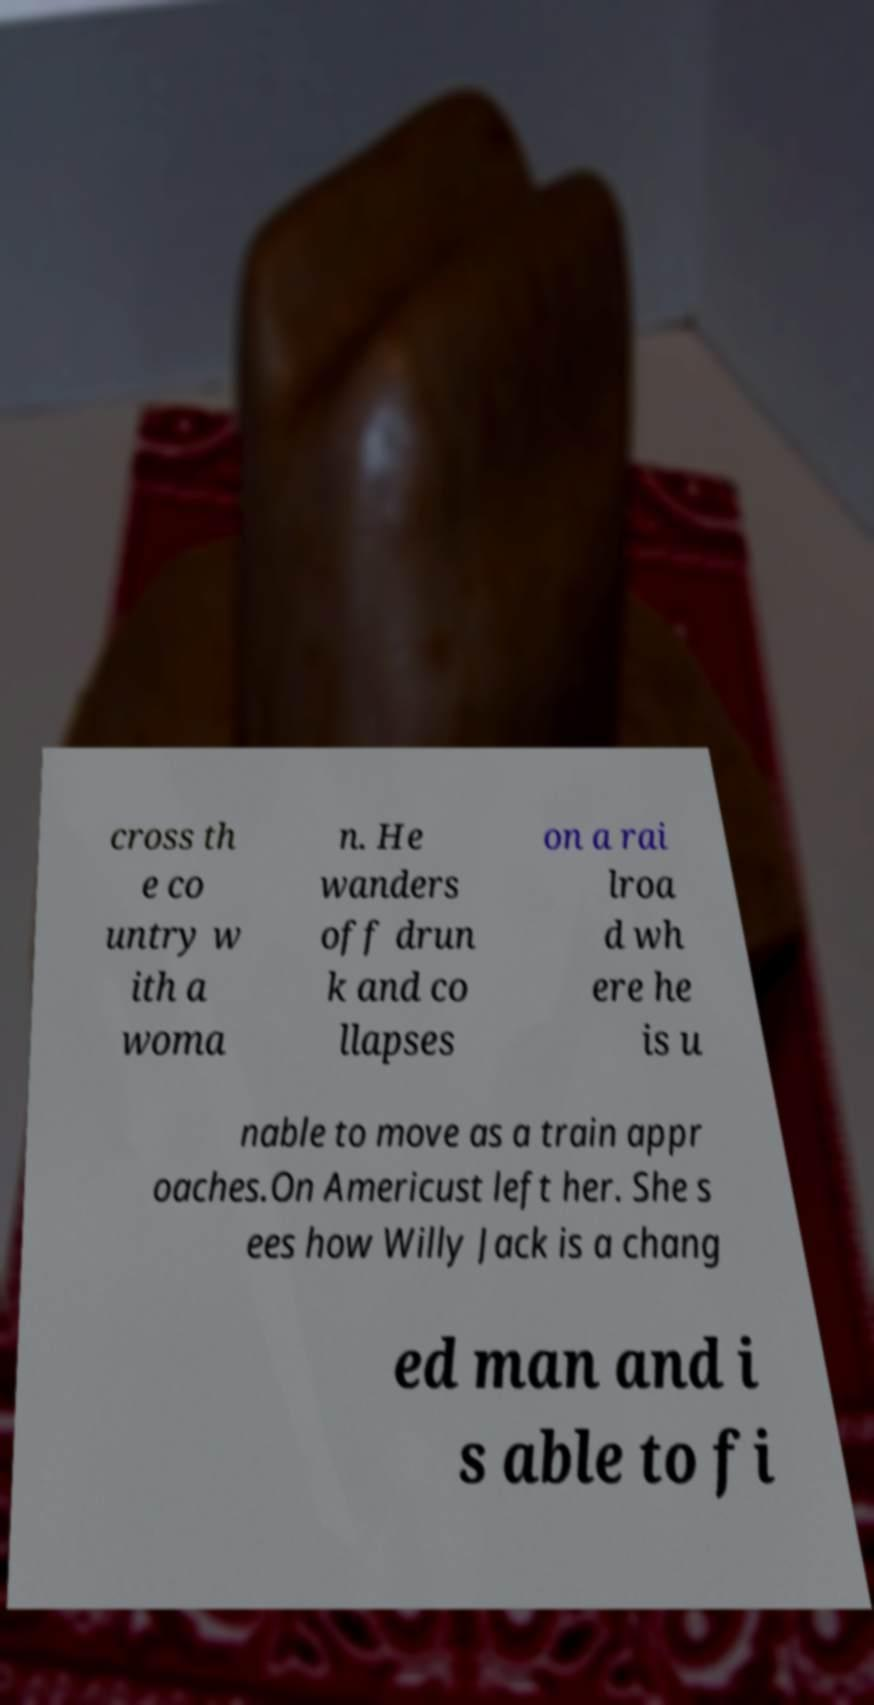There's text embedded in this image that I need extracted. Can you transcribe it verbatim? cross th e co untry w ith a woma n. He wanders off drun k and co llapses on a rai lroa d wh ere he is u nable to move as a train appr oaches.On Americust left her. She s ees how Willy Jack is a chang ed man and i s able to fi 